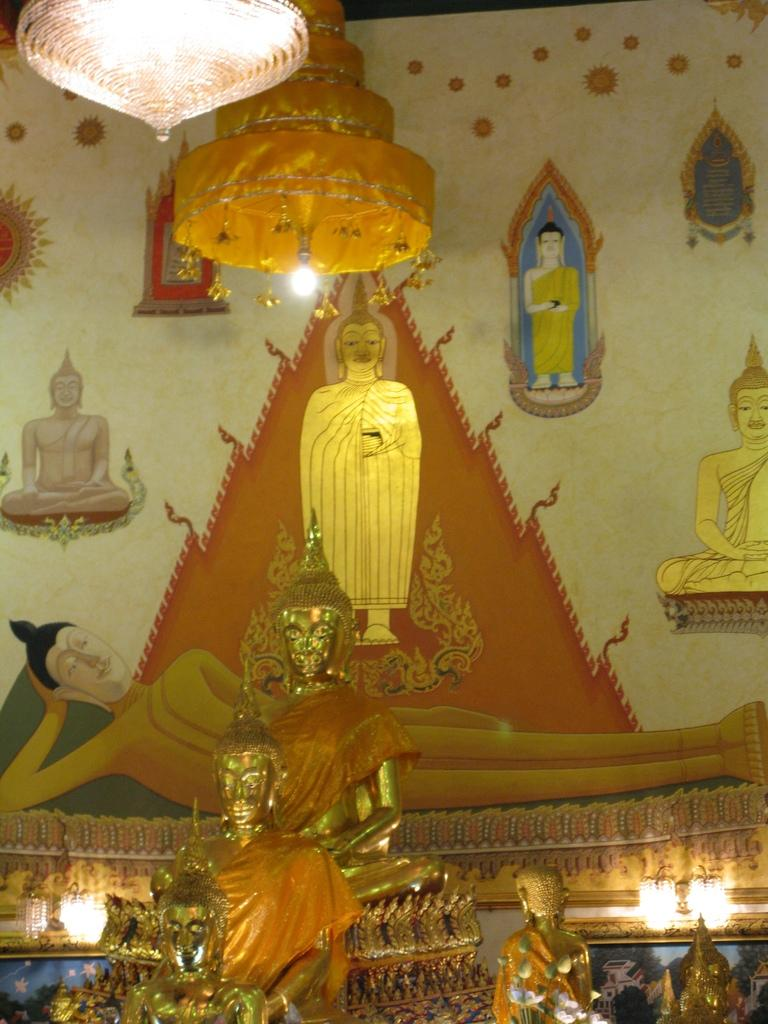What can be seen in the foreground of the image? There are sculptures in the foreground of the image. Where are the sculptures located in relation to the image? The sculptures are at the bottom of the image. What is visible on the wall in the background of the image? There are paintings on the wall in the background of the image. What type of lighting fixture is present at the top of the image? There are chandeliers at the top of the image. What degree of difficulty is required to turn on the faucet in the image? There is no faucet present in the image. How many wrens can be seen in the image? There are no wrens present in the image. 